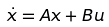<formula> <loc_0><loc_0><loc_500><loc_500>\dot { x } = A x + B u</formula> 